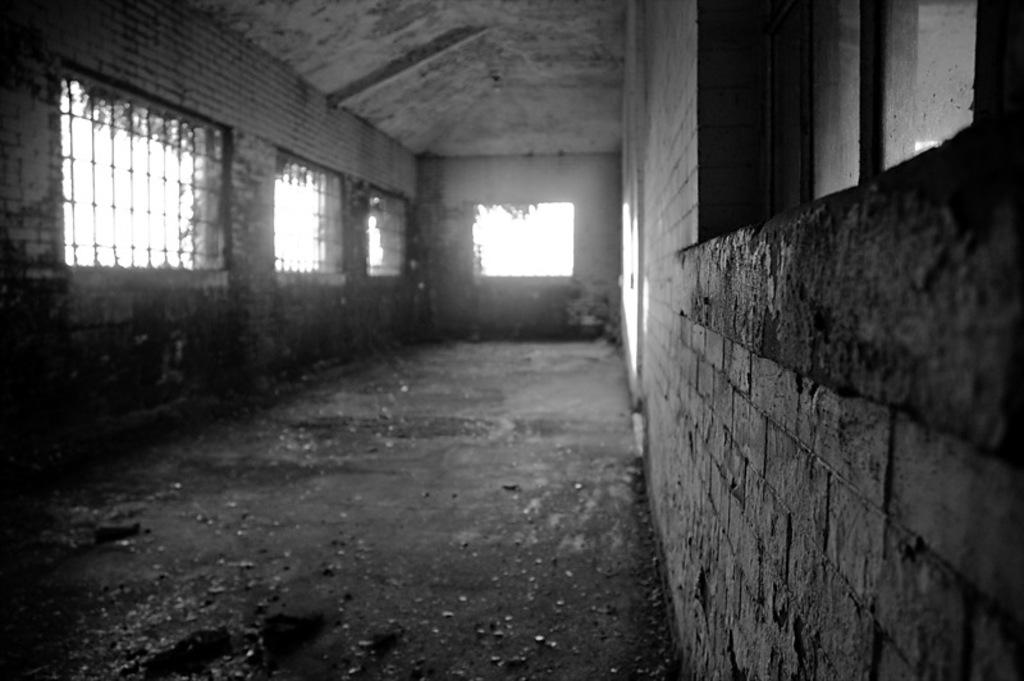What is the color scheme of the image? The image is black and white. What type of architectural feature can be seen in the image? There are grilles in the image. What part of the image is visible beneath the grilles? The floor is visible in the image. What is located on the right side of the image? There is a window and a wall on the right side of the image. How many babies are crawling on the silver floor in the image? There are no babies or silver floor present in the image; it is black and white with grilles, a floor, and a window and wall on the right side. 